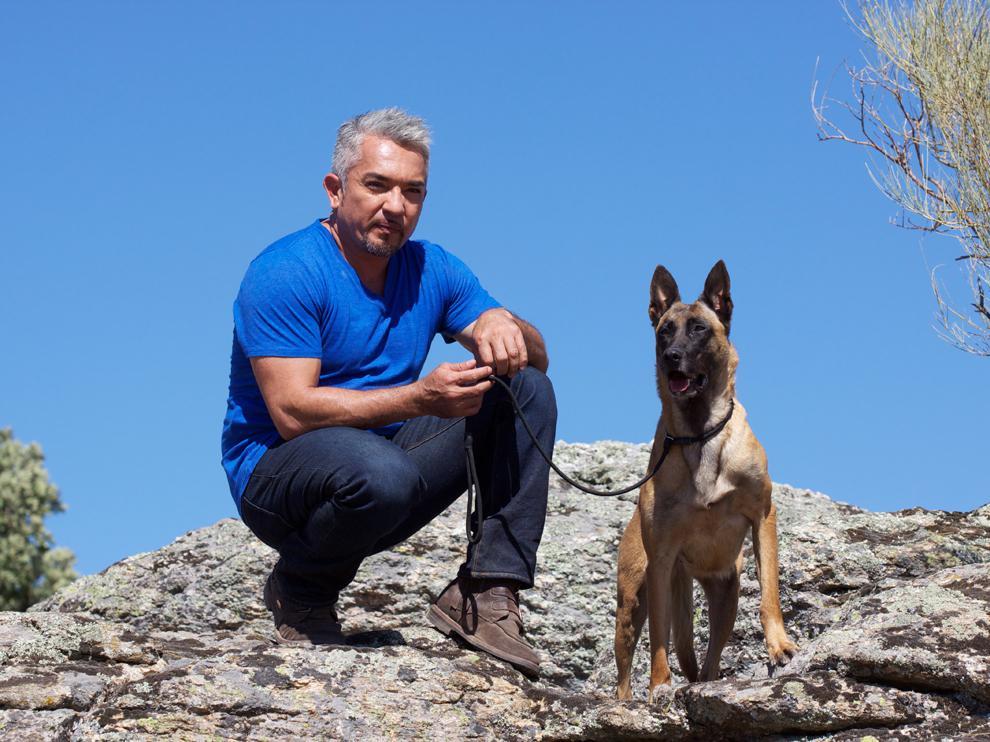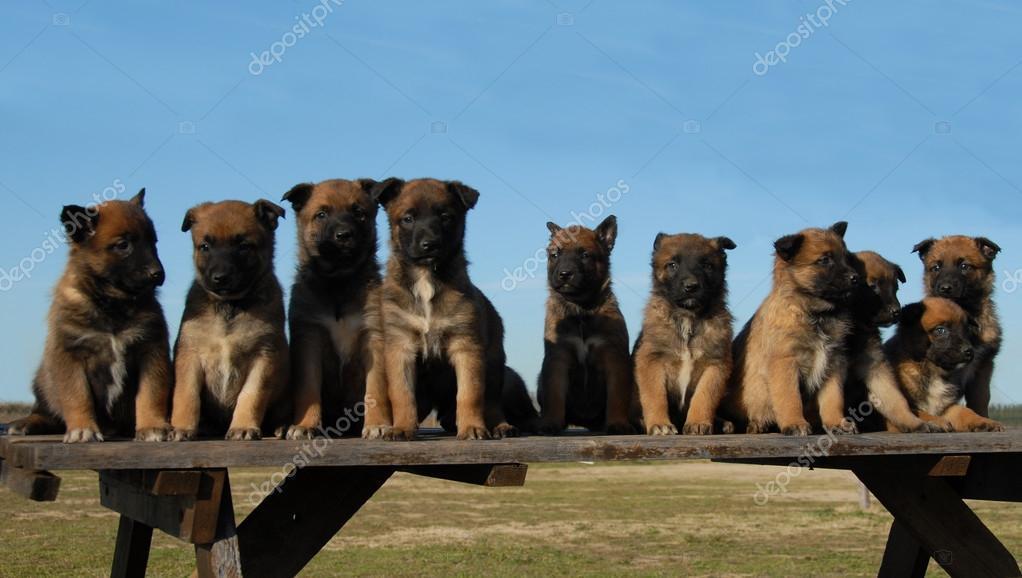The first image is the image on the left, the second image is the image on the right. For the images displayed, is the sentence "At least one person appears in each image." factually correct? Answer yes or no. No. The first image is the image on the left, the second image is the image on the right. Evaluate the accuracy of this statement regarding the images: "There are no less than two humans". Is it true? Answer yes or no. No. 